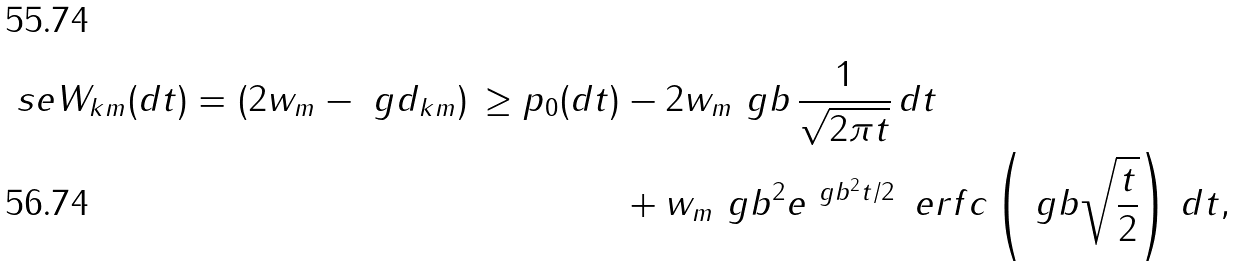Convert formula to latex. <formula><loc_0><loc_0><loc_500><loc_500>\ s e W _ { k m } ( d t ) = ( 2 w _ { m } - \ g d _ { k m } ) \, \geq p _ { 0 } ( d t ) & - 2 w _ { m } \ g b \, \frac { 1 } { \sqrt { 2 \pi t } } \, d t \\ & + w _ { m } \ g b ^ { 2 } e ^ { \ g b ^ { 2 } t / 2 } \, \ e r f c \left ( \ g b \sqrt { \frac { t } { 2 } } \right ) \, d t ,</formula> 